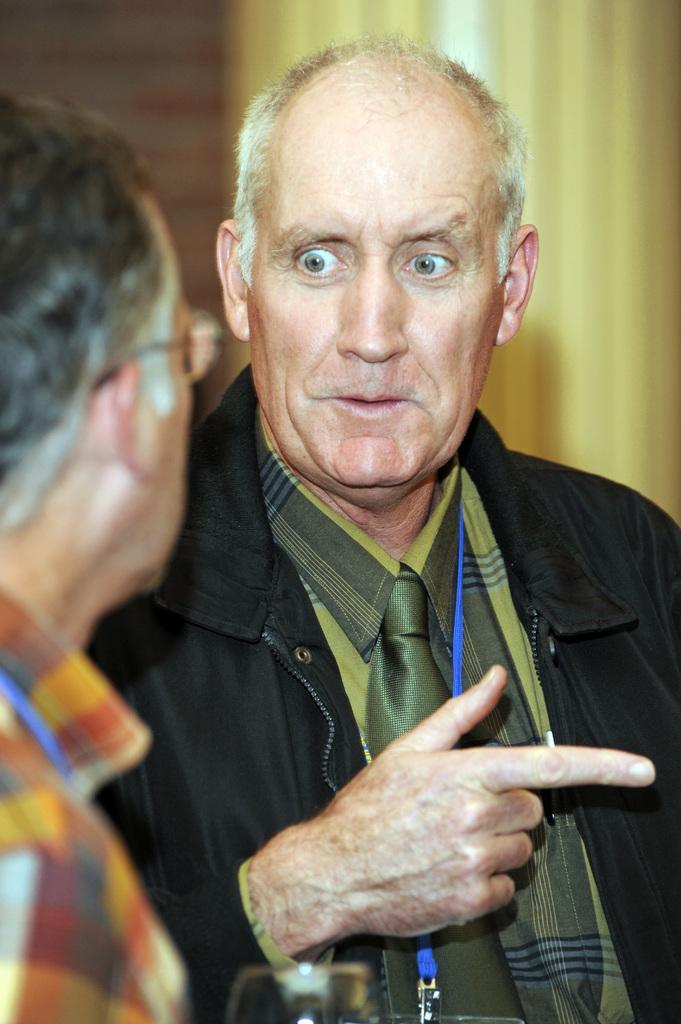How would you summarize this image in a sentence or two? In this image I can see two persons, the person at right is wearing green and black color dress and the person at left is wearing multi color shirt, background I can see few curtains in cream color. 